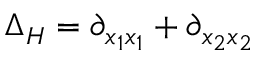<formula> <loc_0><loc_0><loc_500><loc_500>\Delta _ { H } = \partial _ { x _ { 1 } x _ { 1 } } + \partial _ { x _ { 2 } x _ { 2 } }</formula> 